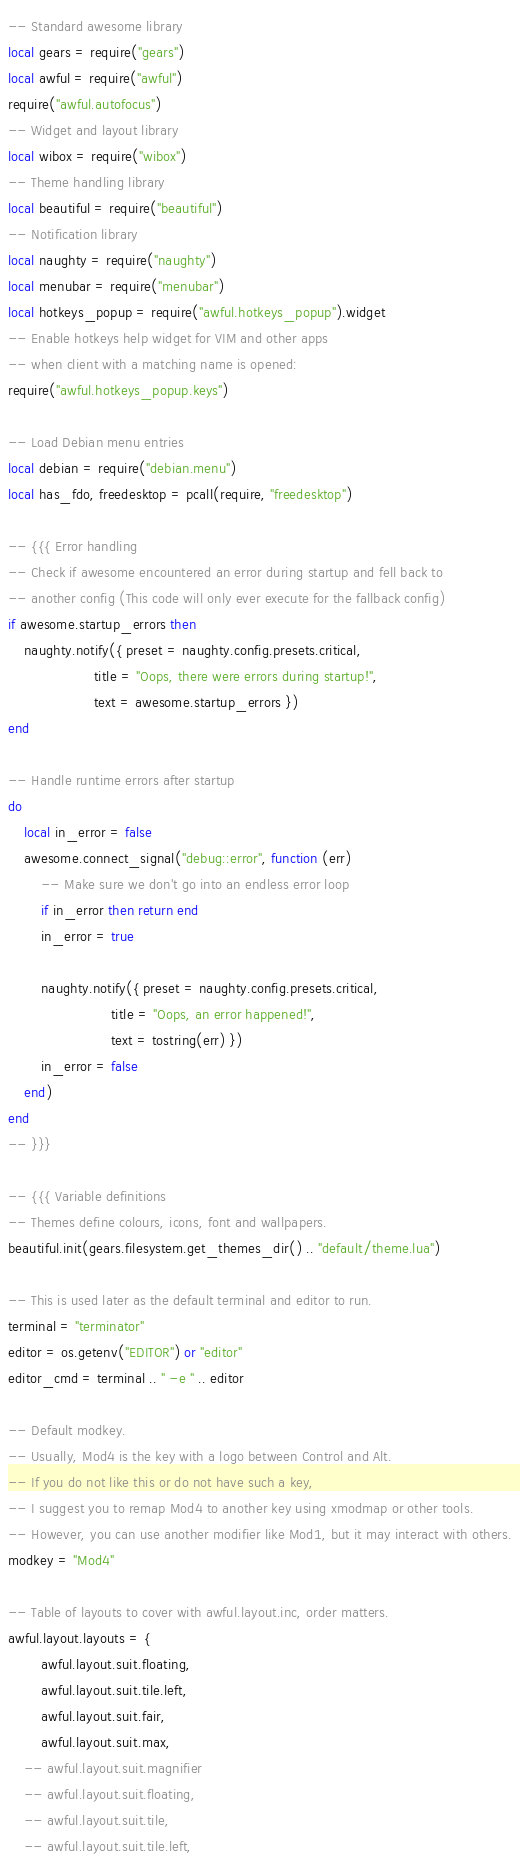<code> <loc_0><loc_0><loc_500><loc_500><_Lua_>-- Standard awesome library
local gears = require("gears")
local awful = require("awful")
require("awful.autofocus")
-- Widget and layout library
local wibox = require("wibox")
-- Theme handling library
local beautiful = require("beautiful")
-- Notification library
local naughty = require("naughty")
local menubar = require("menubar")
local hotkeys_popup = require("awful.hotkeys_popup").widget
-- Enable hotkeys help widget for VIM and other apps
-- when client with a matching name is opened:
require("awful.hotkeys_popup.keys")

-- Load Debian menu entries
local debian = require("debian.menu")
local has_fdo, freedesktop = pcall(require, "freedesktop")

-- {{{ Error handling
-- Check if awesome encountered an error during startup and fell back to
-- another config (This code will only ever execute for the fallback config)
if awesome.startup_errors then
    naughty.notify({ preset = naughty.config.presets.critical,
                     title = "Oops, there were errors during startup!",
                     text = awesome.startup_errors })
end

-- Handle runtime errors after startup
do
    local in_error = false
    awesome.connect_signal("debug::error", function (err)
        -- Make sure we don't go into an endless error loop
        if in_error then return end
        in_error = true

        naughty.notify({ preset = naughty.config.presets.critical,
                         title = "Oops, an error happened!",
                         text = tostring(err) })
        in_error = false
    end)
end
-- }}}

-- {{{ Variable definitions
-- Themes define colours, icons, font and wallpapers.
beautiful.init(gears.filesystem.get_themes_dir() .. "default/theme.lua")

-- This is used later as the default terminal and editor to run.
terminal = "terminator"
editor = os.getenv("EDITOR") or "editor"
editor_cmd = terminal .. " -e " .. editor

-- Default modkey.
-- Usually, Mod4 is the key with a logo between Control and Alt.
-- If you do not like this or do not have such a key,
-- I suggest you to remap Mod4 to another key using xmodmap or other tools.
-- However, you can use another modifier like Mod1, but it may interact with others.
modkey = "Mod4"

-- Table of layouts to cover with awful.layout.inc, order matters.
awful.layout.layouts = {
        awful.layout.suit.floating,
        awful.layout.suit.tile.left,
        awful.layout.suit.fair,
        awful.layout.suit.max,
    -- awful.layout.suit.magnifier
    -- awful.layout.suit.floating,
    -- awful.layout.suit.tile,
    -- awful.layout.suit.tile.left,</code> 